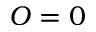<formula> <loc_0><loc_0><loc_500><loc_500>O = 0</formula> 